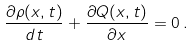<formula> <loc_0><loc_0><loc_500><loc_500>\frac { \partial \rho ( x , t ) } { d t } + \frac { \partial Q ( x , t ) } { \partial x } = 0 \, .</formula> 